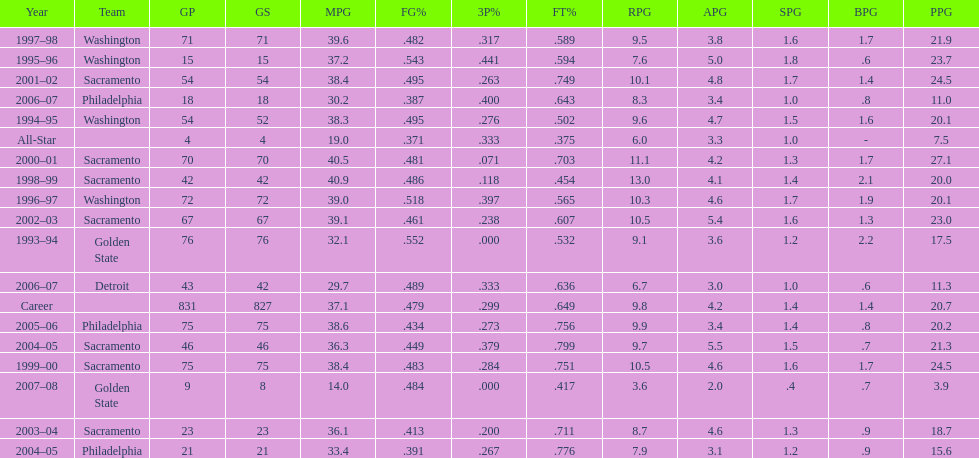How many seasons did webber average over 20 points per game (ppg)? 11. 